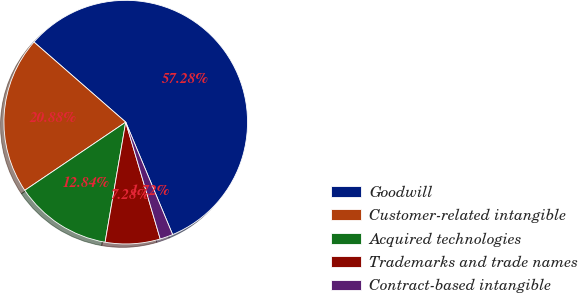<chart> <loc_0><loc_0><loc_500><loc_500><pie_chart><fcel>Goodwill<fcel>Customer-related intangible<fcel>Acquired technologies<fcel>Trademarks and trade names<fcel>Contract-based intangible<nl><fcel>57.29%<fcel>20.88%<fcel>12.84%<fcel>7.28%<fcel>1.72%<nl></chart> 